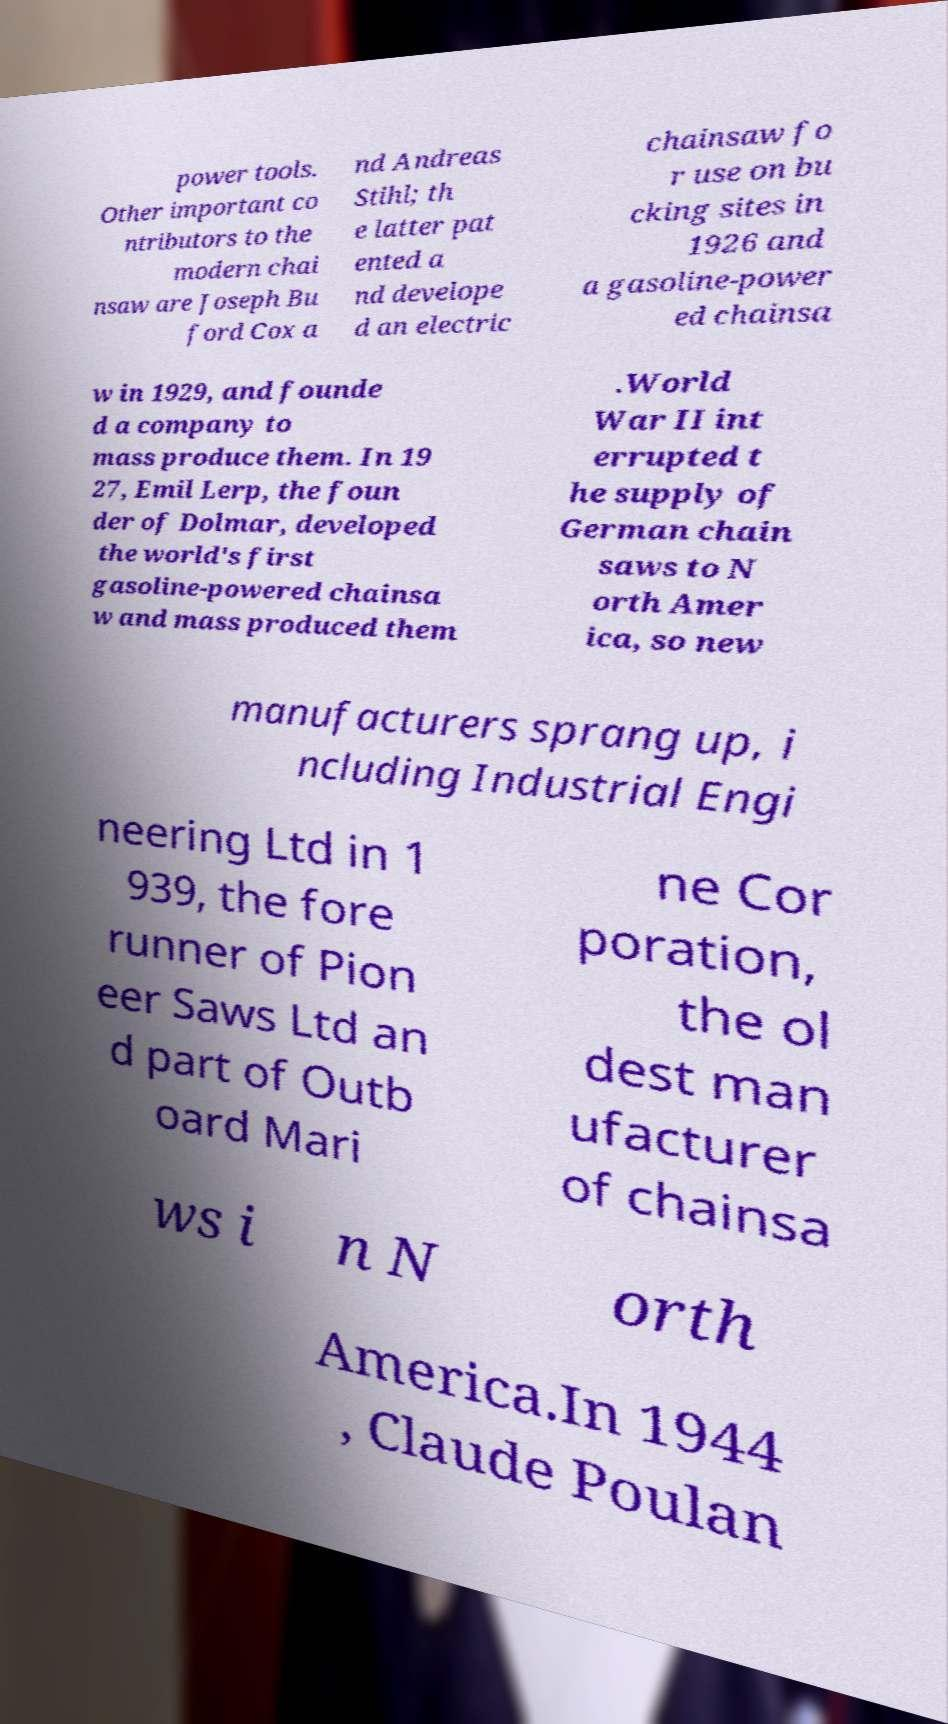What messages or text are displayed in this image? I need them in a readable, typed format. power tools. Other important co ntributors to the modern chai nsaw are Joseph Bu ford Cox a nd Andreas Stihl; th e latter pat ented a nd develope d an electric chainsaw fo r use on bu cking sites in 1926 and a gasoline-power ed chainsa w in 1929, and founde d a company to mass produce them. In 19 27, Emil Lerp, the foun der of Dolmar, developed the world's first gasoline-powered chainsa w and mass produced them .World War II int errupted t he supply of German chain saws to N orth Amer ica, so new manufacturers sprang up, i ncluding Industrial Engi neering Ltd in 1 939, the fore runner of Pion eer Saws Ltd an d part of Outb oard Mari ne Cor poration, the ol dest man ufacturer of chainsa ws i n N orth America.In 1944 , Claude Poulan 